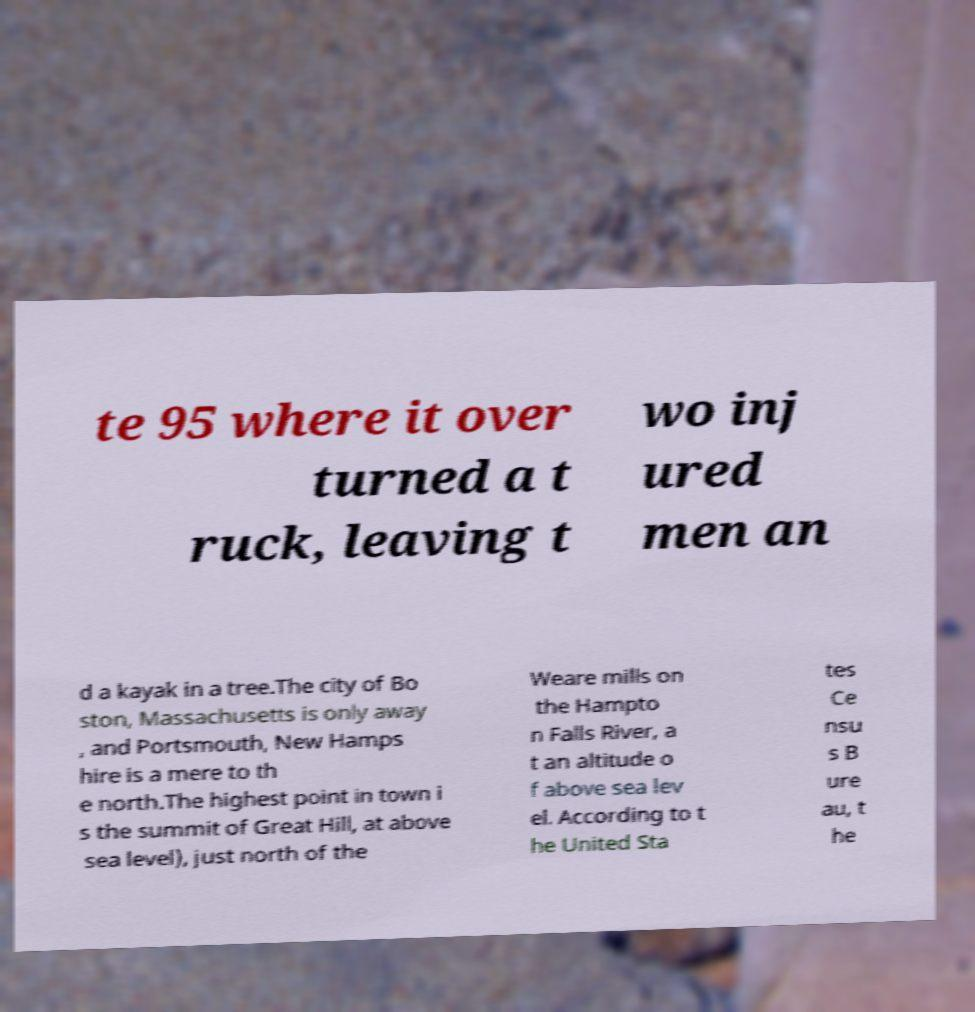Please identify and transcribe the text found in this image. te 95 where it over turned a t ruck, leaving t wo inj ured men an d a kayak in a tree.The city of Bo ston, Massachusetts is only away , and Portsmouth, New Hamps hire is a mere to th e north.The highest point in town i s the summit of Great Hill, at above sea level), just north of the Weare mills on the Hampto n Falls River, a t an altitude o f above sea lev el. According to t he United Sta tes Ce nsu s B ure au, t he 